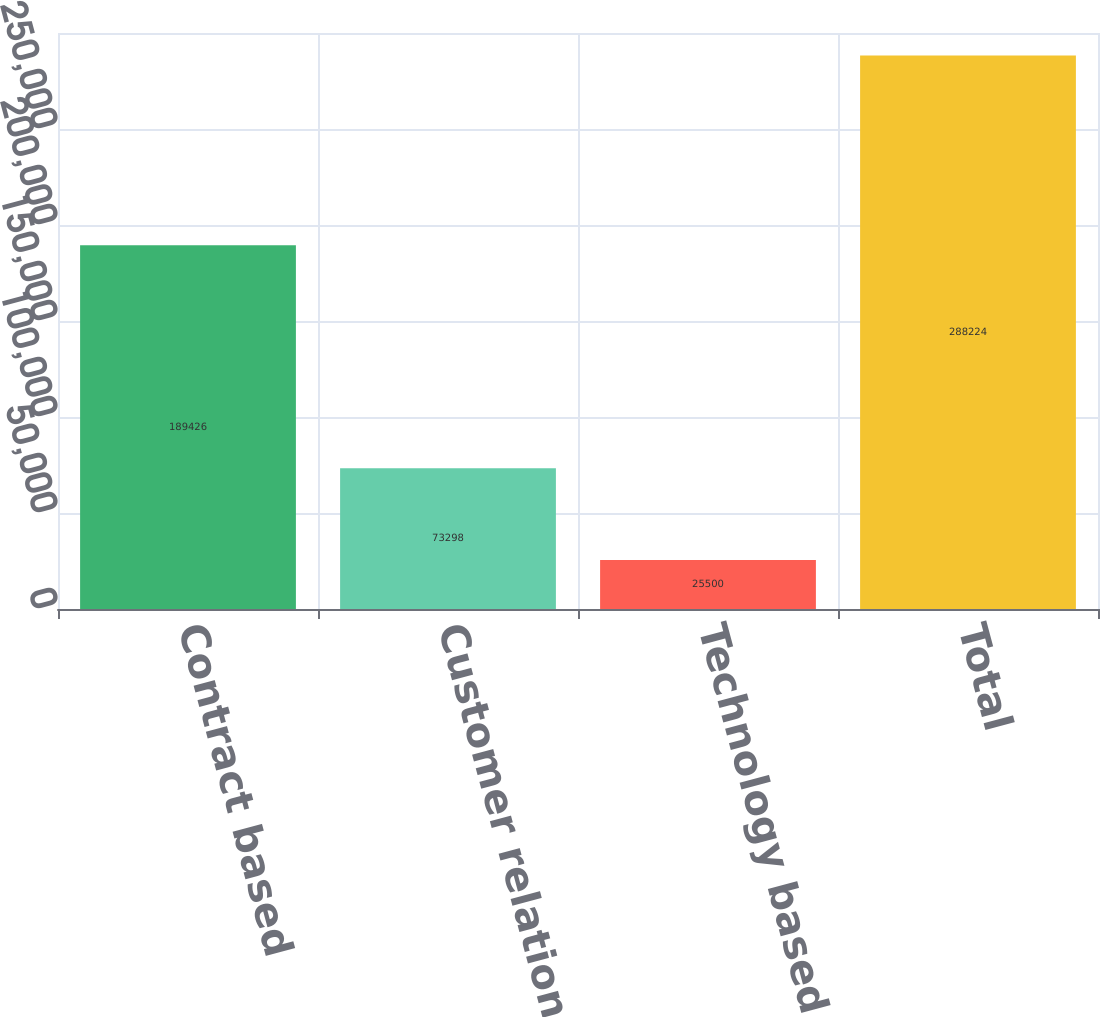<chart> <loc_0><loc_0><loc_500><loc_500><bar_chart><fcel>Contract based<fcel>Customer relationships<fcel>Technology based<fcel>Total<nl><fcel>189426<fcel>73298<fcel>25500<fcel>288224<nl></chart> 